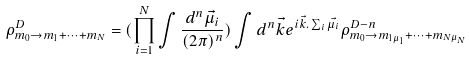<formula> <loc_0><loc_0><loc_500><loc_500>\rho _ { m _ { 0 } \rightarrow m _ { 1 } + \cdots + m _ { N } } ^ { D } = ( \prod _ { i = 1 } ^ { N } \int \frac { d ^ { n } \vec { \mu _ { i } } } { ( 2 \pi ) ^ { n } } ) \int d ^ { n } \vec { k } e ^ { i \vec { k } . \sum _ { i } \vec { \mu _ { i } } } \rho _ { m _ { 0 } \rightarrow m _ { 1 \mu _ { 1 } } + \cdots + m _ { N \mu _ { N } } } ^ { D - n }</formula> 